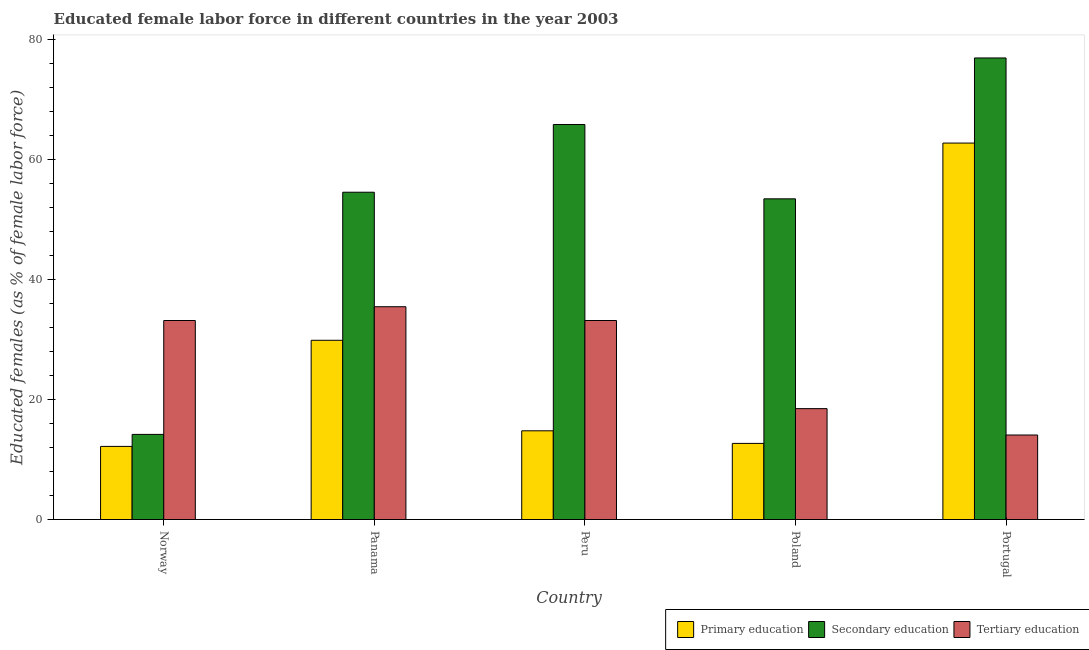How many different coloured bars are there?
Your answer should be compact. 3. How many bars are there on the 3rd tick from the right?
Your answer should be compact. 3. In how many cases, is the number of bars for a given country not equal to the number of legend labels?
Make the answer very short. 0. What is the percentage of female labor force who received primary education in Norway?
Ensure brevity in your answer.  12.2. Across all countries, what is the maximum percentage of female labor force who received tertiary education?
Your answer should be very brief. 35.5. Across all countries, what is the minimum percentage of female labor force who received tertiary education?
Offer a very short reply. 14.1. In which country was the percentage of female labor force who received secondary education minimum?
Your answer should be compact. Norway. What is the total percentage of female labor force who received tertiary education in the graph?
Provide a short and direct response. 134.5. What is the difference between the percentage of female labor force who received secondary education in Norway and that in Panama?
Make the answer very short. -40.4. What is the difference between the percentage of female labor force who received tertiary education in Norway and the percentage of female labor force who received primary education in Peru?
Your answer should be very brief. 18.4. What is the average percentage of female labor force who received tertiary education per country?
Give a very brief answer. 26.9. What is the difference between the percentage of female labor force who received primary education and percentage of female labor force who received tertiary education in Poland?
Ensure brevity in your answer.  -5.8. What is the ratio of the percentage of female labor force who received primary education in Norway to that in Portugal?
Make the answer very short. 0.19. Is the percentage of female labor force who received tertiary education in Panama less than that in Portugal?
Your response must be concise. No. What is the difference between the highest and the second highest percentage of female labor force who received primary education?
Keep it short and to the point. 32.9. What is the difference between the highest and the lowest percentage of female labor force who received tertiary education?
Keep it short and to the point. 21.4. In how many countries, is the percentage of female labor force who received tertiary education greater than the average percentage of female labor force who received tertiary education taken over all countries?
Ensure brevity in your answer.  3. What does the 2nd bar from the left in Norway represents?
Make the answer very short. Secondary education. What does the 3rd bar from the right in Portugal represents?
Your answer should be compact. Primary education. How many bars are there?
Your response must be concise. 15. Does the graph contain any zero values?
Ensure brevity in your answer.  No. What is the title of the graph?
Your response must be concise. Educated female labor force in different countries in the year 2003. Does "Resident buildings and public services" appear as one of the legend labels in the graph?
Offer a terse response. No. What is the label or title of the Y-axis?
Your answer should be very brief. Educated females (as % of female labor force). What is the Educated females (as % of female labor force) of Primary education in Norway?
Your answer should be very brief. 12.2. What is the Educated females (as % of female labor force) of Secondary education in Norway?
Your answer should be very brief. 14.2. What is the Educated females (as % of female labor force) of Tertiary education in Norway?
Provide a succinct answer. 33.2. What is the Educated females (as % of female labor force) of Primary education in Panama?
Your answer should be compact. 29.9. What is the Educated females (as % of female labor force) in Secondary education in Panama?
Provide a short and direct response. 54.6. What is the Educated females (as % of female labor force) in Tertiary education in Panama?
Make the answer very short. 35.5. What is the Educated females (as % of female labor force) in Primary education in Peru?
Ensure brevity in your answer.  14.8. What is the Educated females (as % of female labor force) in Secondary education in Peru?
Ensure brevity in your answer.  65.9. What is the Educated females (as % of female labor force) of Tertiary education in Peru?
Ensure brevity in your answer.  33.2. What is the Educated females (as % of female labor force) in Primary education in Poland?
Ensure brevity in your answer.  12.7. What is the Educated females (as % of female labor force) of Secondary education in Poland?
Offer a terse response. 53.5. What is the Educated females (as % of female labor force) in Primary education in Portugal?
Offer a very short reply. 62.8. What is the Educated females (as % of female labor force) of Secondary education in Portugal?
Your answer should be compact. 77. What is the Educated females (as % of female labor force) in Tertiary education in Portugal?
Provide a short and direct response. 14.1. Across all countries, what is the maximum Educated females (as % of female labor force) of Primary education?
Make the answer very short. 62.8. Across all countries, what is the maximum Educated females (as % of female labor force) in Tertiary education?
Ensure brevity in your answer.  35.5. Across all countries, what is the minimum Educated females (as % of female labor force) of Primary education?
Your answer should be compact. 12.2. Across all countries, what is the minimum Educated females (as % of female labor force) of Secondary education?
Your answer should be very brief. 14.2. Across all countries, what is the minimum Educated females (as % of female labor force) in Tertiary education?
Offer a terse response. 14.1. What is the total Educated females (as % of female labor force) in Primary education in the graph?
Provide a succinct answer. 132.4. What is the total Educated females (as % of female labor force) in Secondary education in the graph?
Give a very brief answer. 265.2. What is the total Educated females (as % of female labor force) in Tertiary education in the graph?
Your response must be concise. 134.5. What is the difference between the Educated females (as % of female labor force) of Primary education in Norway and that in Panama?
Your answer should be compact. -17.7. What is the difference between the Educated females (as % of female labor force) of Secondary education in Norway and that in Panama?
Ensure brevity in your answer.  -40.4. What is the difference between the Educated females (as % of female labor force) in Tertiary education in Norway and that in Panama?
Ensure brevity in your answer.  -2.3. What is the difference between the Educated females (as % of female labor force) in Primary education in Norway and that in Peru?
Provide a succinct answer. -2.6. What is the difference between the Educated females (as % of female labor force) of Secondary education in Norway and that in Peru?
Offer a terse response. -51.7. What is the difference between the Educated females (as % of female labor force) of Secondary education in Norway and that in Poland?
Your answer should be very brief. -39.3. What is the difference between the Educated females (as % of female labor force) of Tertiary education in Norway and that in Poland?
Make the answer very short. 14.7. What is the difference between the Educated females (as % of female labor force) in Primary education in Norway and that in Portugal?
Make the answer very short. -50.6. What is the difference between the Educated females (as % of female labor force) of Secondary education in Norway and that in Portugal?
Provide a succinct answer. -62.8. What is the difference between the Educated females (as % of female labor force) of Secondary education in Panama and that in Peru?
Keep it short and to the point. -11.3. What is the difference between the Educated females (as % of female labor force) of Primary education in Panama and that in Poland?
Your answer should be compact. 17.2. What is the difference between the Educated females (as % of female labor force) in Secondary education in Panama and that in Poland?
Your response must be concise. 1.1. What is the difference between the Educated females (as % of female labor force) of Tertiary education in Panama and that in Poland?
Your response must be concise. 17. What is the difference between the Educated females (as % of female labor force) of Primary education in Panama and that in Portugal?
Make the answer very short. -32.9. What is the difference between the Educated females (as % of female labor force) in Secondary education in Panama and that in Portugal?
Your answer should be compact. -22.4. What is the difference between the Educated females (as % of female labor force) in Tertiary education in Panama and that in Portugal?
Provide a succinct answer. 21.4. What is the difference between the Educated females (as % of female labor force) of Primary education in Peru and that in Portugal?
Provide a short and direct response. -48. What is the difference between the Educated females (as % of female labor force) of Tertiary education in Peru and that in Portugal?
Make the answer very short. 19.1. What is the difference between the Educated females (as % of female labor force) in Primary education in Poland and that in Portugal?
Keep it short and to the point. -50.1. What is the difference between the Educated females (as % of female labor force) of Secondary education in Poland and that in Portugal?
Keep it short and to the point. -23.5. What is the difference between the Educated females (as % of female labor force) in Tertiary education in Poland and that in Portugal?
Your response must be concise. 4.4. What is the difference between the Educated females (as % of female labor force) in Primary education in Norway and the Educated females (as % of female labor force) in Secondary education in Panama?
Your response must be concise. -42.4. What is the difference between the Educated females (as % of female labor force) of Primary education in Norway and the Educated females (as % of female labor force) of Tertiary education in Panama?
Your response must be concise. -23.3. What is the difference between the Educated females (as % of female labor force) of Secondary education in Norway and the Educated females (as % of female labor force) of Tertiary education in Panama?
Ensure brevity in your answer.  -21.3. What is the difference between the Educated females (as % of female labor force) of Primary education in Norway and the Educated females (as % of female labor force) of Secondary education in Peru?
Ensure brevity in your answer.  -53.7. What is the difference between the Educated females (as % of female labor force) in Secondary education in Norway and the Educated females (as % of female labor force) in Tertiary education in Peru?
Offer a very short reply. -19. What is the difference between the Educated females (as % of female labor force) of Primary education in Norway and the Educated females (as % of female labor force) of Secondary education in Poland?
Ensure brevity in your answer.  -41.3. What is the difference between the Educated females (as % of female labor force) of Primary education in Norway and the Educated females (as % of female labor force) of Tertiary education in Poland?
Give a very brief answer. -6.3. What is the difference between the Educated females (as % of female labor force) of Secondary education in Norway and the Educated females (as % of female labor force) of Tertiary education in Poland?
Your response must be concise. -4.3. What is the difference between the Educated females (as % of female labor force) of Primary education in Norway and the Educated females (as % of female labor force) of Secondary education in Portugal?
Your answer should be compact. -64.8. What is the difference between the Educated females (as % of female labor force) of Primary education in Norway and the Educated females (as % of female labor force) of Tertiary education in Portugal?
Give a very brief answer. -1.9. What is the difference between the Educated females (as % of female labor force) in Secondary education in Norway and the Educated females (as % of female labor force) in Tertiary education in Portugal?
Keep it short and to the point. 0.1. What is the difference between the Educated females (as % of female labor force) in Primary education in Panama and the Educated females (as % of female labor force) in Secondary education in Peru?
Your answer should be compact. -36. What is the difference between the Educated females (as % of female labor force) in Secondary education in Panama and the Educated females (as % of female labor force) in Tertiary education in Peru?
Give a very brief answer. 21.4. What is the difference between the Educated females (as % of female labor force) in Primary education in Panama and the Educated females (as % of female labor force) in Secondary education in Poland?
Your response must be concise. -23.6. What is the difference between the Educated females (as % of female labor force) in Primary education in Panama and the Educated females (as % of female labor force) in Tertiary education in Poland?
Offer a very short reply. 11.4. What is the difference between the Educated females (as % of female labor force) in Secondary education in Panama and the Educated females (as % of female labor force) in Tertiary education in Poland?
Your answer should be compact. 36.1. What is the difference between the Educated females (as % of female labor force) of Primary education in Panama and the Educated females (as % of female labor force) of Secondary education in Portugal?
Provide a short and direct response. -47.1. What is the difference between the Educated females (as % of female labor force) of Primary education in Panama and the Educated females (as % of female labor force) of Tertiary education in Portugal?
Ensure brevity in your answer.  15.8. What is the difference between the Educated females (as % of female labor force) of Secondary education in Panama and the Educated females (as % of female labor force) of Tertiary education in Portugal?
Keep it short and to the point. 40.5. What is the difference between the Educated females (as % of female labor force) of Primary education in Peru and the Educated females (as % of female labor force) of Secondary education in Poland?
Provide a short and direct response. -38.7. What is the difference between the Educated females (as % of female labor force) in Secondary education in Peru and the Educated females (as % of female labor force) in Tertiary education in Poland?
Keep it short and to the point. 47.4. What is the difference between the Educated females (as % of female labor force) in Primary education in Peru and the Educated females (as % of female labor force) in Secondary education in Portugal?
Provide a short and direct response. -62.2. What is the difference between the Educated females (as % of female labor force) in Secondary education in Peru and the Educated females (as % of female labor force) in Tertiary education in Portugal?
Ensure brevity in your answer.  51.8. What is the difference between the Educated females (as % of female labor force) of Primary education in Poland and the Educated females (as % of female labor force) of Secondary education in Portugal?
Ensure brevity in your answer.  -64.3. What is the difference between the Educated females (as % of female labor force) in Secondary education in Poland and the Educated females (as % of female labor force) in Tertiary education in Portugal?
Make the answer very short. 39.4. What is the average Educated females (as % of female labor force) in Primary education per country?
Your answer should be very brief. 26.48. What is the average Educated females (as % of female labor force) of Secondary education per country?
Offer a terse response. 53.04. What is the average Educated females (as % of female labor force) of Tertiary education per country?
Provide a succinct answer. 26.9. What is the difference between the Educated females (as % of female labor force) in Primary education and Educated females (as % of female labor force) in Secondary education in Norway?
Offer a very short reply. -2. What is the difference between the Educated females (as % of female labor force) in Primary education and Educated females (as % of female labor force) in Tertiary education in Norway?
Give a very brief answer. -21. What is the difference between the Educated females (as % of female labor force) of Primary education and Educated females (as % of female labor force) of Secondary education in Panama?
Keep it short and to the point. -24.7. What is the difference between the Educated females (as % of female labor force) of Secondary education and Educated females (as % of female labor force) of Tertiary education in Panama?
Provide a succinct answer. 19.1. What is the difference between the Educated females (as % of female labor force) in Primary education and Educated females (as % of female labor force) in Secondary education in Peru?
Your response must be concise. -51.1. What is the difference between the Educated females (as % of female labor force) of Primary education and Educated females (as % of female labor force) of Tertiary education in Peru?
Offer a very short reply. -18.4. What is the difference between the Educated females (as % of female labor force) of Secondary education and Educated females (as % of female labor force) of Tertiary education in Peru?
Offer a very short reply. 32.7. What is the difference between the Educated females (as % of female labor force) of Primary education and Educated females (as % of female labor force) of Secondary education in Poland?
Provide a succinct answer. -40.8. What is the difference between the Educated females (as % of female labor force) of Secondary education and Educated females (as % of female labor force) of Tertiary education in Poland?
Make the answer very short. 35. What is the difference between the Educated females (as % of female labor force) in Primary education and Educated females (as % of female labor force) in Secondary education in Portugal?
Your response must be concise. -14.2. What is the difference between the Educated females (as % of female labor force) in Primary education and Educated females (as % of female labor force) in Tertiary education in Portugal?
Your response must be concise. 48.7. What is the difference between the Educated females (as % of female labor force) in Secondary education and Educated females (as % of female labor force) in Tertiary education in Portugal?
Ensure brevity in your answer.  62.9. What is the ratio of the Educated females (as % of female labor force) of Primary education in Norway to that in Panama?
Make the answer very short. 0.41. What is the ratio of the Educated females (as % of female labor force) in Secondary education in Norway to that in Panama?
Your answer should be very brief. 0.26. What is the ratio of the Educated females (as % of female labor force) of Tertiary education in Norway to that in Panama?
Your answer should be very brief. 0.94. What is the ratio of the Educated females (as % of female labor force) in Primary education in Norway to that in Peru?
Offer a very short reply. 0.82. What is the ratio of the Educated females (as % of female labor force) of Secondary education in Norway to that in Peru?
Offer a terse response. 0.22. What is the ratio of the Educated females (as % of female labor force) of Tertiary education in Norway to that in Peru?
Make the answer very short. 1. What is the ratio of the Educated females (as % of female labor force) of Primary education in Norway to that in Poland?
Keep it short and to the point. 0.96. What is the ratio of the Educated females (as % of female labor force) in Secondary education in Norway to that in Poland?
Make the answer very short. 0.27. What is the ratio of the Educated females (as % of female labor force) in Tertiary education in Norway to that in Poland?
Offer a very short reply. 1.79. What is the ratio of the Educated females (as % of female labor force) of Primary education in Norway to that in Portugal?
Offer a terse response. 0.19. What is the ratio of the Educated females (as % of female labor force) in Secondary education in Norway to that in Portugal?
Ensure brevity in your answer.  0.18. What is the ratio of the Educated females (as % of female labor force) in Tertiary education in Norway to that in Portugal?
Give a very brief answer. 2.35. What is the ratio of the Educated females (as % of female labor force) of Primary education in Panama to that in Peru?
Give a very brief answer. 2.02. What is the ratio of the Educated females (as % of female labor force) in Secondary education in Panama to that in Peru?
Provide a succinct answer. 0.83. What is the ratio of the Educated females (as % of female labor force) in Tertiary education in Panama to that in Peru?
Your response must be concise. 1.07. What is the ratio of the Educated females (as % of female labor force) of Primary education in Panama to that in Poland?
Offer a terse response. 2.35. What is the ratio of the Educated females (as % of female labor force) of Secondary education in Panama to that in Poland?
Provide a succinct answer. 1.02. What is the ratio of the Educated females (as % of female labor force) in Tertiary education in Panama to that in Poland?
Provide a short and direct response. 1.92. What is the ratio of the Educated females (as % of female labor force) of Primary education in Panama to that in Portugal?
Your answer should be compact. 0.48. What is the ratio of the Educated females (as % of female labor force) of Secondary education in Panama to that in Portugal?
Make the answer very short. 0.71. What is the ratio of the Educated females (as % of female labor force) of Tertiary education in Panama to that in Portugal?
Provide a succinct answer. 2.52. What is the ratio of the Educated females (as % of female labor force) of Primary education in Peru to that in Poland?
Your response must be concise. 1.17. What is the ratio of the Educated females (as % of female labor force) in Secondary education in Peru to that in Poland?
Your response must be concise. 1.23. What is the ratio of the Educated females (as % of female labor force) in Tertiary education in Peru to that in Poland?
Offer a terse response. 1.79. What is the ratio of the Educated females (as % of female labor force) in Primary education in Peru to that in Portugal?
Keep it short and to the point. 0.24. What is the ratio of the Educated females (as % of female labor force) in Secondary education in Peru to that in Portugal?
Provide a short and direct response. 0.86. What is the ratio of the Educated females (as % of female labor force) of Tertiary education in Peru to that in Portugal?
Provide a succinct answer. 2.35. What is the ratio of the Educated females (as % of female labor force) of Primary education in Poland to that in Portugal?
Offer a terse response. 0.2. What is the ratio of the Educated females (as % of female labor force) of Secondary education in Poland to that in Portugal?
Provide a short and direct response. 0.69. What is the ratio of the Educated females (as % of female labor force) in Tertiary education in Poland to that in Portugal?
Your answer should be very brief. 1.31. What is the difference between the highest and the second highest Educated females (as % of female labor force) in Primary education?
Provide a short and direct response. 32.9. What is the difference between the highest and the second highest Educated females (as % of female labor force) in Tertiary education?
Provide a short and direct response. 2.3. What is the difference between the highest and the lowest Educated females (as % of female labor force) in Primary education?
Offer a terse response. 50.6. What is the difference between the highest and the lowest Educated females (as % of female labor force) in Secondary education?
Make the answer very short. 62.8. What is the difference between the highest and the lowest Educated females (as % of female labor force) in Tertiary education?
Offer a very short reply. 21.4. 